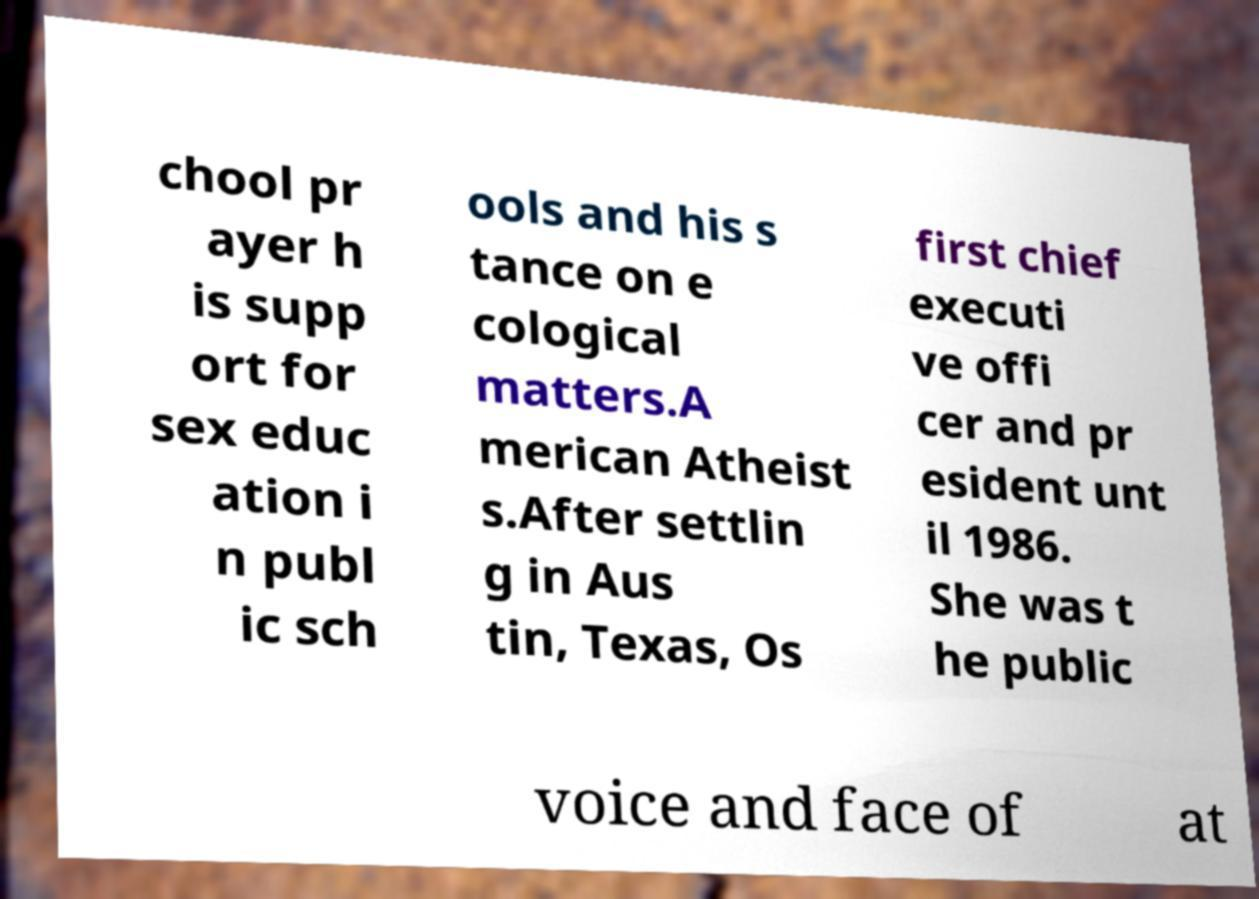There's text embedded in this image that I need extracted. Can you transcribe it verbatim? chool pr ayer h is supp ort for sex educ ation i n publ ic sch ools and his s tance on e cological matters.A merican Atheist s.After settlin g in Aus tin, Texas, Os first chief executi ve offi cer and pr esident unt il 1986. She was t he public voice and face of at 